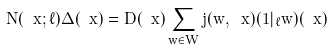<formula> <loc_0><loc_0><loc_500><loc_500>N ( \ x ; \ell ) \Delta ( \ x ) = D ( \ x ) \sum _ { w \in W } j ( w , \ x ) ( 1 | _ { \ell } w ) ( \ x )</formula> 